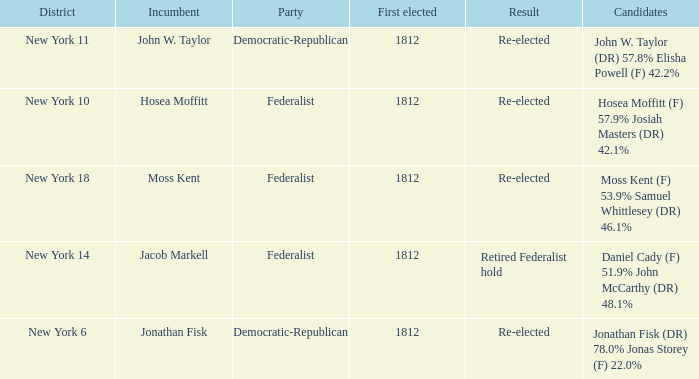Name the incumbent for new york 10 Hosea Moffitt. 